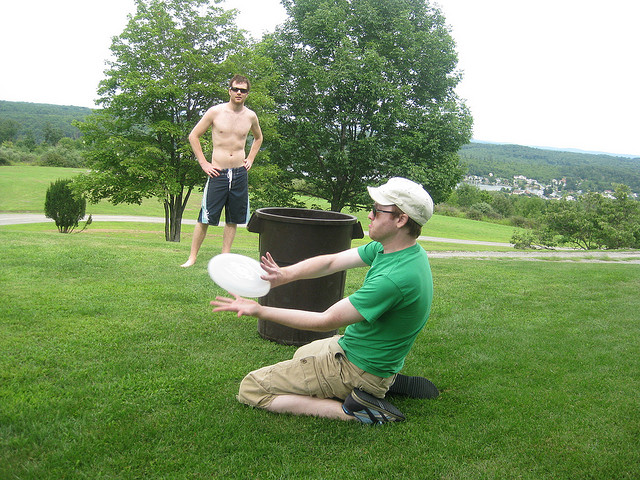What might be the relationship between the two individuals in the image? The two individuals likely share a friendly or familial relationship, suggested by their comfortable and informal interaction during the game. Their casual attire and shared activity hint at a relaxed and enjoyable outing together, perhaps as friends or family members enjoying a weekend. 